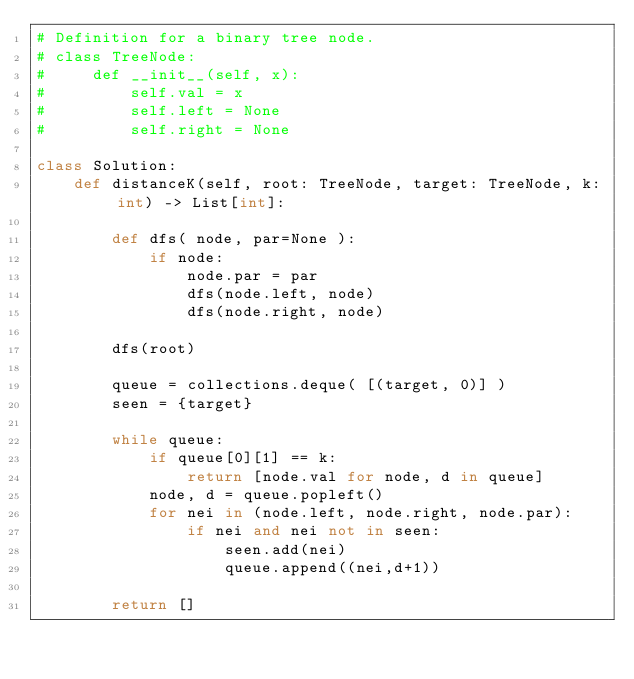Convert code to text. <code><loc_0><loc_0><loc_500><loc_500><_Python_># Definition for a binary tree node.
# class TreeNode:
#     def __init__(self, x):
#         self.val = x
#         self.left = None
#         self.right = None

class Solution:
    def distanceK(self, root: TreeNode, target: TreeNode, k: int) -> List[int]:
        
        def dfs( node, par=None ):
            if node:
                node.par = par
                dfs(node.left, node)
                dfs(node.right, node)
                
        dfs(root)
        
        queue = collections.deque( [(target, 0)] )
        seen = {target}
        
        while queue:
            if queue[0][1] == k:
                return [node.val for node, d in queue]
            node, d = queue.popleft()
            for nei in (node.left, node.right, node.par):
                if nei and nei not in seen:
                    seen.add(nei)
                    queue.append((nei,d+1))
                    
        return []
</code> 